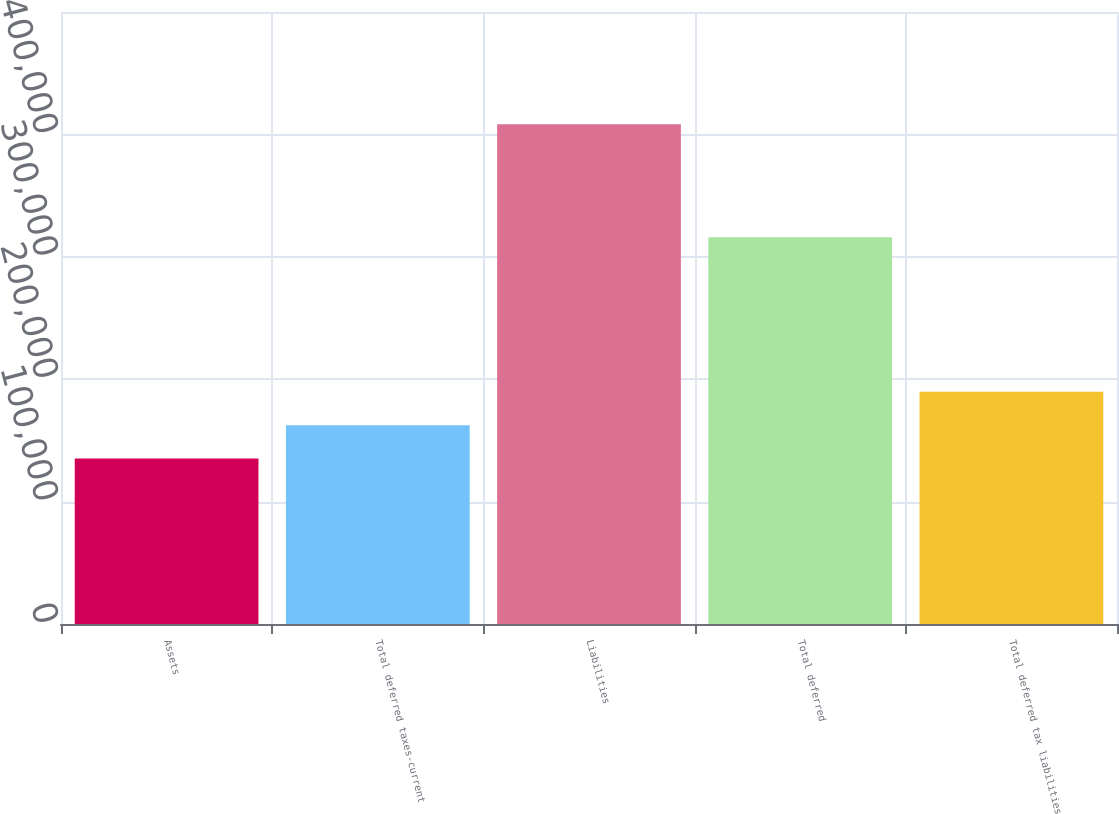<chart> <loc_0><loc_0><loc_500><loc_500><bar_chart><fcel>Assets<fcel>Total deferred taxes-current<fcel>Liabilities<fcel>Total deferred<fcel>Total deferred tax liabilities<nl><fcel>135120<fcel>162436<fcel>408283<fcel>315900<fcel>189753<nl></chart> 